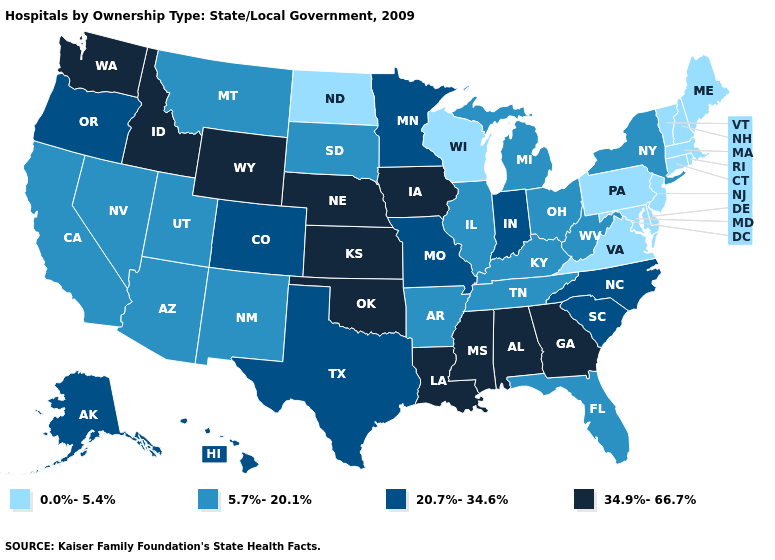Among the states that border Arkansas , which have the highest value?
Give a very brief answer. Louisiana, Mississippi, Oklahoma. Which states hav the highest value in the South?
Give a very brief answer. Alabama, Georgia, Louisiana, Mississippi, Oklahoma. Is the legend a continuous bar?
Quick response, please. No. Does Idaho have the highest value in the USA?
Quick response, please. Yes. Does Wisconsin have the lowest value in the MidWest?
Write a very short answer. Yes. What is the value of Arkansas?
Give a very brief answer. 5.7%-20.1%. Name the states that have a value in the range 0.0%-5.4%?
Short answer required. Connecticut, Delaware, Maine, Maryland, Massachusetts, New Hampshire, New Jersey, North Dakota, Pennsylvania, Rhode Island, Vermont, Virginia, Wisconsin. Name the states that have a value in the range 20.7%-34.6%?
Give a very brief answer. Alaska, Colorado, Hawaii, Indiana, Minnesota, Missouri, North Carolina, Oregon, South Carolina, Texas. Does New Mexico have the same value as Michigan?
Short answer required. Yes. Name the states that have a value in the range 5.7%-20.1%?
Write a very short answer. Arizona, Arkansas, California, Florida, Illinois, Kentucky, Michigan, Montana, Nevada, New Mexico, New York, Ohio, South Dakota, Tennessee, Utah, West Virginia. Does the first symbol in the legend represent the smallest category?
Give a very brief answer. Yes. Does the map have missing data?
Short answer required. No. Which states have the lowest value in the West?
Be succinct. Arizona, California, Montana, Nevada, New Mexico, Utah. Does the first symbol in the legend represent the smallest category?
Short answer required. Yes. What is the lowest value in the USA?
Give a very brief answer. 0.0%-5.4%. 